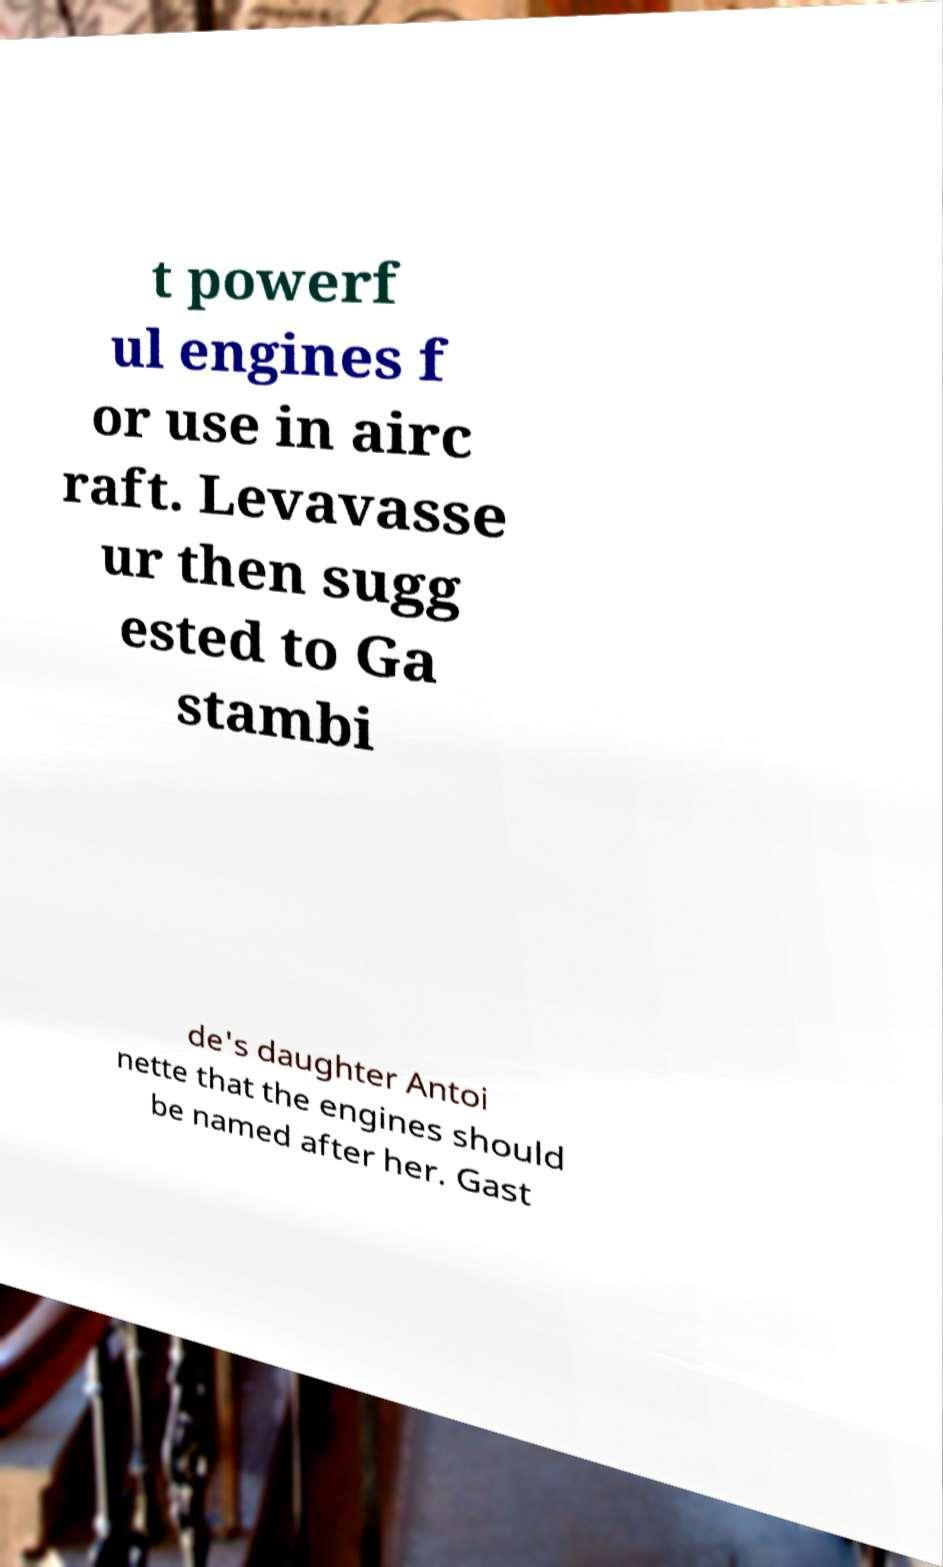There's text embedded in this image that I need extracted. Can you transcribe it verbatim? t powerf ul engines f or use in airc raft. Levavasse ur then sugg ested to Ga stambi de's daughter Antoi nette that the engines should be named after her. Gast 